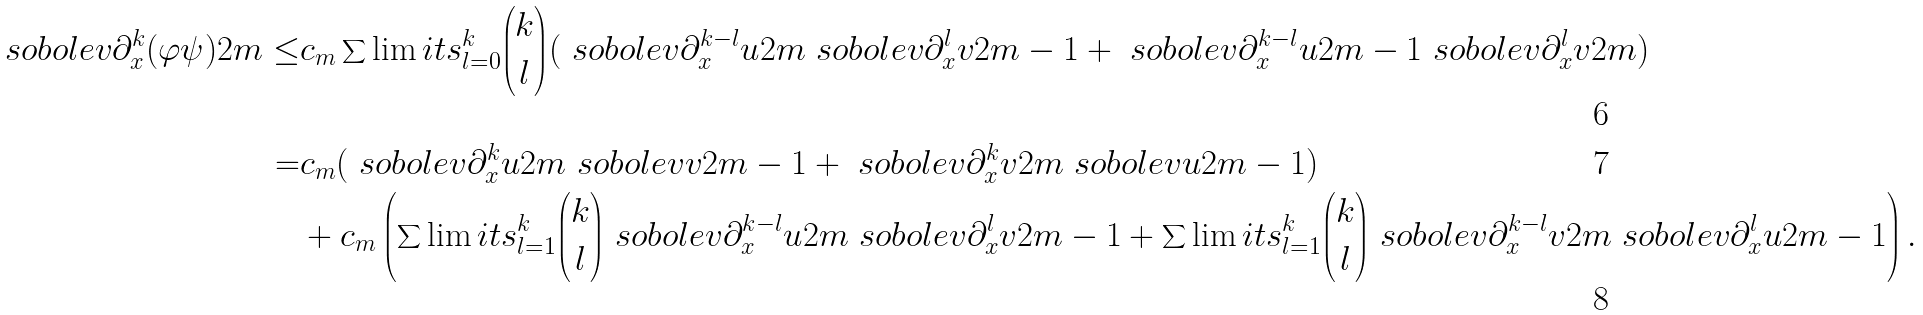<formula> <loc_0><loc_0><loc_500><loc_500>\ s o b o l e v { \partial _ { x } ^ { k } ( \varphi \psi ) } { 2 m } \leq & c _ { m } \sum \lim i t s _ { l = 0 } ^ { k } \binom { k } { l } ( \ s o b o l e v { \partial _ { x } ^ { k - l } u } { 2 m } \ s o b o l e v { \partial _ { x } ^ { l } v } { 2 m - 1 } + \ s o b o l e v { \partial _ { x } ^ { k - l } u } { 2 m - 1 } \ s o b o l e v { \partial _ { x } ^ { l } v } { 2 m } ) \\ = & c _ { m } ( \ s o b o l e v { \partial _ { x } ^ { k } u } { 2 m } \ s o b o l e v { v } { 2 m - 1 } + \ s o b o l e v { \partial _ { x } ^ { k } v } { 2 m } \ s o b o l e v { u } { 2 m - 1 } ) \\ & + c _ { m } \left ( \sum \lim i t s _ { l = 1 } ^ { k } \binom { k } { l } \ s o b o l e v { \partial _ { x } ^ { k - l } u } { 2 m } \ s o b o l e v { \partial _ { x } ^ { l } v } { 2 m - 1 } + \sum \lim i t s _ { l = 1 } ^ { k } \binom { k } { l } \ s o b o l e v { \partial _ { x } ^ { k - l } v } { 2 m } \ s o b o l e v { \partial _ { x } ^ { l } u } { 2 m - 1 } \right ) .</formula> 